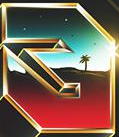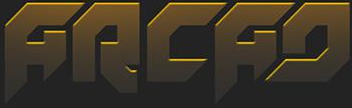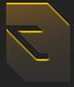Identify the words shown in these images in order, separated by a semicolon. #; ARCAD; # 